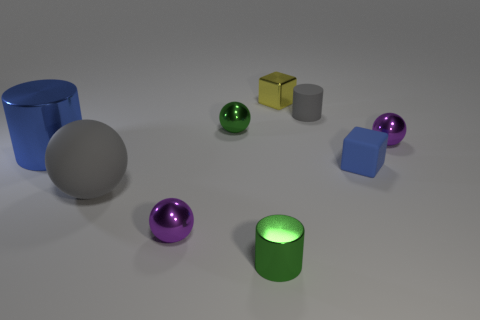Subtract 2 spheres. How many spheres are left? 2 Subtract all shiny cylinders. How many cylinders are left? 1 Subtract all cubes. How many objects are left? 7 Subtract all purple objects. Subtract all tiny yellow metal blocks. How many objects are left? 6 Add 8 gray rubber objects. How many gray rubber objects are left? 10 Add 4 tiny yellow blocks. How many tiny yellow blocks exist? 5 Subtract all gray spheres. How many spheres are left? 3 Subtract 0 cyan cubes. How many objects are left? 9 Subtract all brown cylinders. Subtract all blue cubes. How many cylinders are left? 3 Subtract all green balls. How many yellow blocks are left? 1 